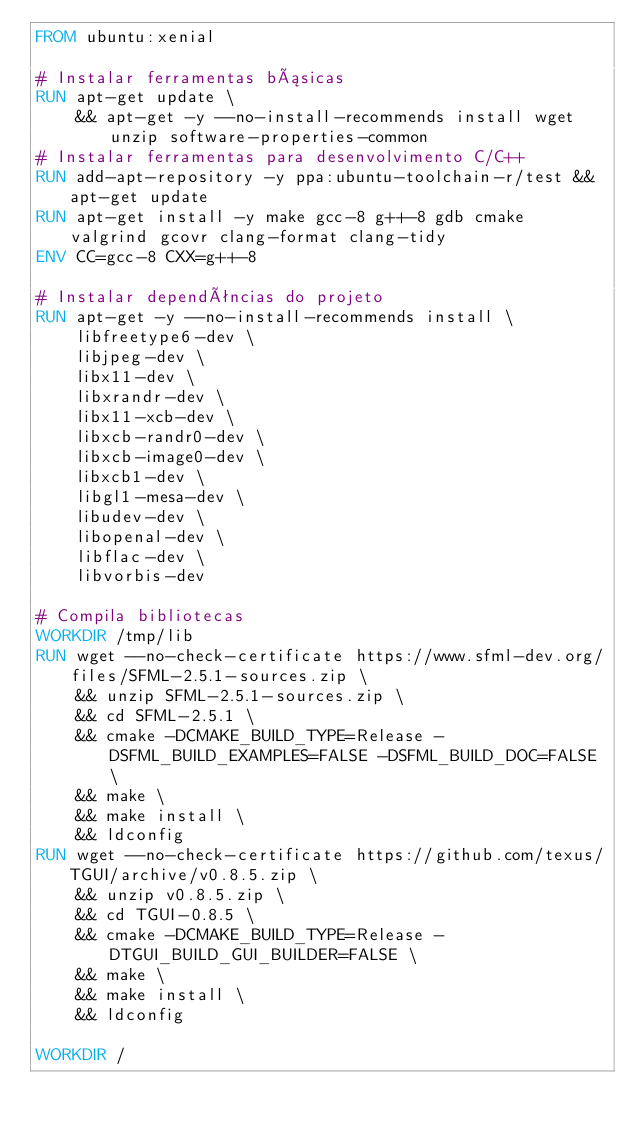<code> <loc_0><loc_0><loc_500><loc_500><_Dockerfile_>FROM ubuntu:xenial

# Instalar ferramentas básicas
RUN apt-get update \ 
    && apt-get -y --no-install-recommends install wget unzip software-properties-common
# Instalar ferramentas para desenvolvimento C/C++
RUN add-apt-repository -y ppa:ubuntu-toolchain-r/test && apt-get update
RUN apt-get install -y make gcc-8 g++-8 gdb cmake valgrind gcovr clang-format clang-tidy
ENV CC=gcc-8 CXX=g++-8

# Instalar dependências do projeto
RUN apt-get -y --no-install-recommends install \
    libfreetype6-dev \ 
    libjpeg-dev \ 
    libx11-dev \ 
    libxrandr-dev \ 
    libx11-xcb-dev \ 
    libxcb-randr0-dev \ 
    libxcb-image0-dev \ 
    libxcb1-dev \ 
    libgl1-mesa-dev \ 
    libudev-dev \ 
    libopenal-dev \ 
    libflac-dev \ 
    libvorbis-dev

# Compila bibliotecas
WORKDIR /tmp/lib
RUN wget --no-check-certificate https://www.sfml-dev.org/files/SFML-2.5.1-sources.zip \
    && unzip SFML-2.5.1-sources.zip \
    && cd SFML-2.5.1 \
    && cmake -DCMAKE_BUILD_TYPE=Release -DSFML_BUILD_EXAMPLES=FALSE -DSFML_BUILD_DOC=FALSE \
    && make \
    && make install \
    && ldconfig
RUN wget --no-check-certificate https://github.com/texus/TGUI/archive/v0.8.5.zip \
    && unzip v0.8.5.zip \
    && cd TGUI-0.8.5 \
    && cmake -DCMAKE_BUILD_TYPE=Release -DTGUI_BUILD_GUI_BUILDER=FALSE \
    && make \
    && make install \
    && ldconfig

WORKDIR /
</code> 